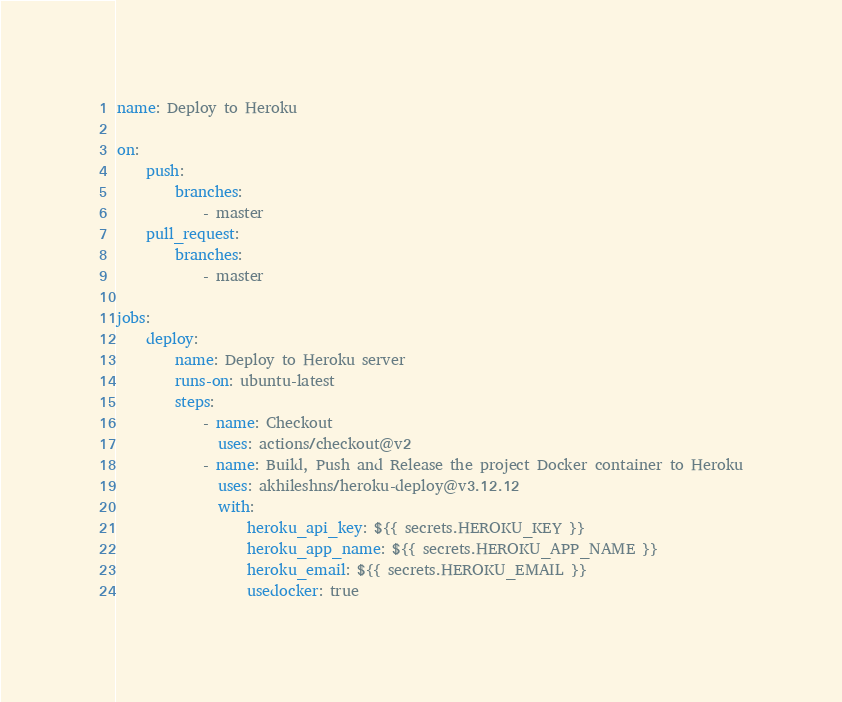<code> <loc_0><loc_0><loc_500><loc_500><_YAML_>name: Deploy to Heroku

on:
    push:
        branches:
            - master
    pull_request:
        branches:
            - master

jobs:
    deploy:
        name: Deploy to Heroku server
        runs-on: ubuntu-latest
        steps:
            - name: Checkout
              uses: actions/checkout@v2
            - name: Build, Push and Release the project Docker container to Heroku
              uses: akhileshns/heroku-deploy@v3.12.12
              with:
                  heroku_api_key: ${{ secrets.HEROKU_KEY }}
                  heroku_app_name: ${{ secrets.HEROKU_APP_NAME }}
                  heroku_email: ${{ secrets.HEROKU_EMAIL }}
                  usedocker: true
</code> 